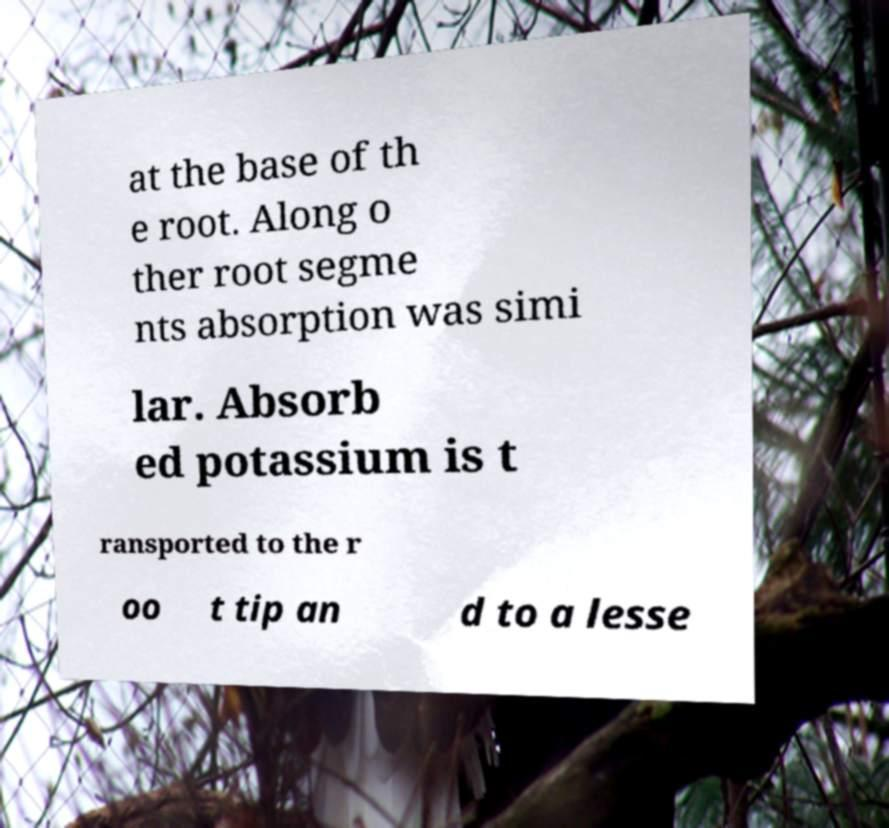Could you extract and type out the text from this image? at the base of th e root. Along o ther root segme nts absorption was simi lar. Absorb ed potassium is t ransported to the r oo t tip an d to a lesse 